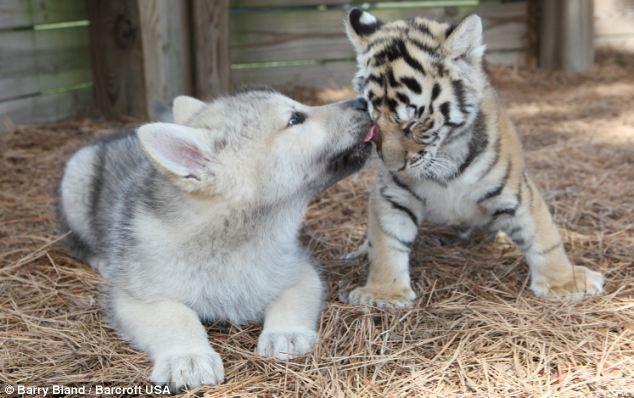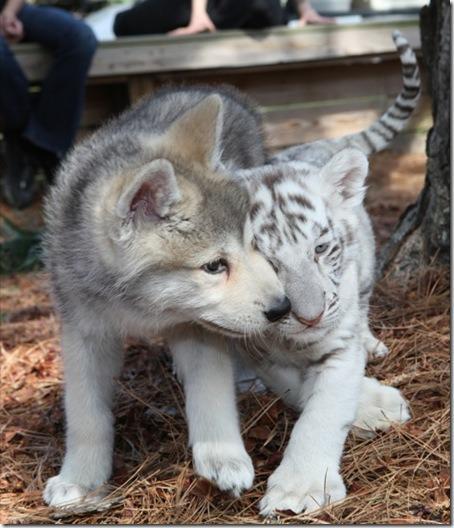The first image is the image on the left, the second image is the image on the right. Considering the images on both sides, is "There are at least three wolves standing in the snow." valid? Answer yes or no. No. 